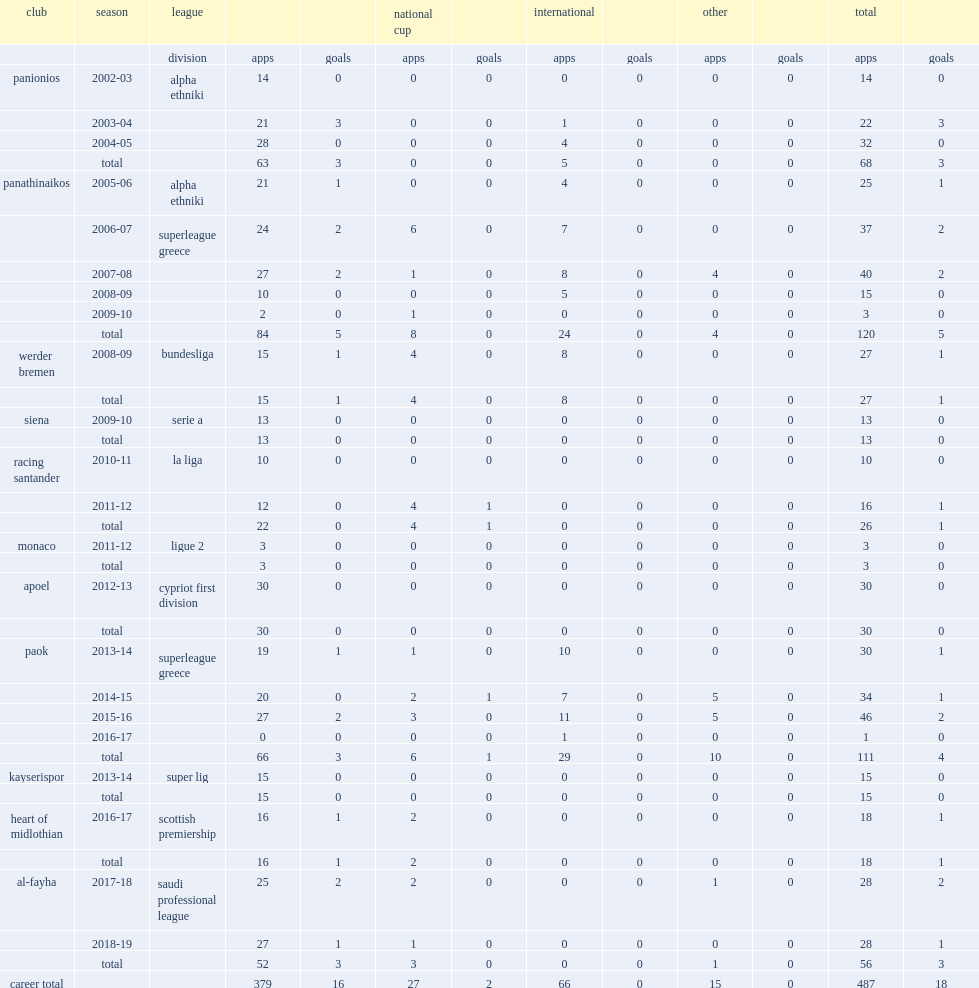Could you help me parse every detail presented in this table? {'header': ['club', 'season', 'league', '', '', 'national cup', '', 'international', '', 'other', '', 'total', ''], 'rows': [['', '', 'division', 'apps', 'goals', 'apps', 'goals', 'apps', 'goals', 'apps', 'goals', 'apps', 'goals'], ['panionios', '2002-03', 'alpha ethniki', '14', '0', '0', '0', '0', '0', '0', '0', '14', '0'], ['', '2003-04', '', '21', '3', '0', '0', '1', '0', '0', '0', '22', '3'], ['', '2004-05', '', '28', '0', '0', '0', '4', '0', '0', '0', '32', '0'], ['', 'total', '', '63', '3', '0', '0', '5', '0', '0', '0', '68', '3'], ['panathinaikos', '2005-06', 'alpha ethniki', '21', '1', '0', '0', '4', '0', '0', '0', '25', '1'], ['', '2006-07', 'superleague greece', '24', '2', '6', '0', '7', '0', '0', '0', '37', '2'], ['', '2007-08', '', '27', '2', '1', '0', '8', '0', '4', '0', '40', '2'], ['', '2008-09', '', '10', '0', '0', '0', '5', '0', '0', '0', '15', '0'], ['', '2009-10', '', '2', '0', '1', '0', '0', '0', '0', '0', '3', '0'], ['', 'total', '', '84', '5', '8', '0', '24', '0', '4', '0', '120', '5'], ['werder bremen', '2008-09', 'bundesliga', '15', '1', '4', '0', '8', '0', '0', '0', '27', '1'], ['', 'total', '', '15', '1', '4', '0', '8', '0', '0', '0', '27', '1'], ['siena', '2009-10', 'serie a', '13', '0', '0', '0', '0', '0', '0', '0', '13', '0'], ['', 'total', '', '13', '0', '0', '0', '0', '0', '0', '0', '13', '0'], ['racing santander', '2010-11', 'la liga', '10', '0', '0', '0', '0', '0', '0', '0', '10', '0'], ['', '2011-12', '', '12', '0', '4', '1', '0', '0', '0', '0', '16', '1'], ['', 'total', '', '22', '0', '4', '1', '0', '0', '0', '0', '26', '1'], ['monaco', '2011-12', 'ligue 2', '3', '0', '0', '0', '0', '0', '0', '0', '3', '0'], ['', 'total', '', '3', '0', '0', '0', '0', '0', '0', '0', '3', '0'], ['apoel', '2012-13', 'cypriot first division', '30', '0', '0', '0', '0', '0', '0', '0', '30', '0'], ['', 'total', '', '30', '0', '0', '0', '0', '0', '0', '0', '30', '0'], ['paok', '2013-14', 'superleague greece', '19', '1', '1', '0', '10', '0', '0', '0', '30', '1'], ['', '2014-15', '', '20', '0', '2', '1', '7', '0', '5', '0', '34', '1'], ['', '2015-16', '', '27', '2', '3', '0', '11', '0', '5', '0', '46', '2'], ['', '2016-17', '', '0', '0', '0', '0', '1', '0', '0', '0', '1', '0'], ['', 'total', '', '66', '3', '6', '1', '29', '0', '10', '0', '111', '4'], ['kayserispor', '2013-14', 'super lig', '15', '0', '0', '0', '0', '0', '0', '0', '15', '0'], ['', 'total', '', '15', '0', '0', '0', '0', '0', '0', '0', '15', '0'], ['heart of midlothian', '2016-17', 'scottish premiership', '16', '1', '2', '0', '0', '0', '0', '0', '18', '1'], ['', 'total', '', '16', '1', '2', '0', '0', '0', '0', '0', '18', '1'], ['al-fayha', '2017-18', 'saudi professional league', '25', '2', '2', '0', '0', '0', '1', '0', '28', '2'], ['', '2018-19', '', '27', '1', '1', '0', '0', '0', '0', '0', '28', '1'], ['', 'total', '', '52', '3', '3', '0', '0', '0', '1', '0', '56', '3'], ['career total', '', '', '379', '16', '27', '2', '66', '0', '15', '0', '487', '18']]} How many appearances did alexandros tziolis make in paok? 111.0. 